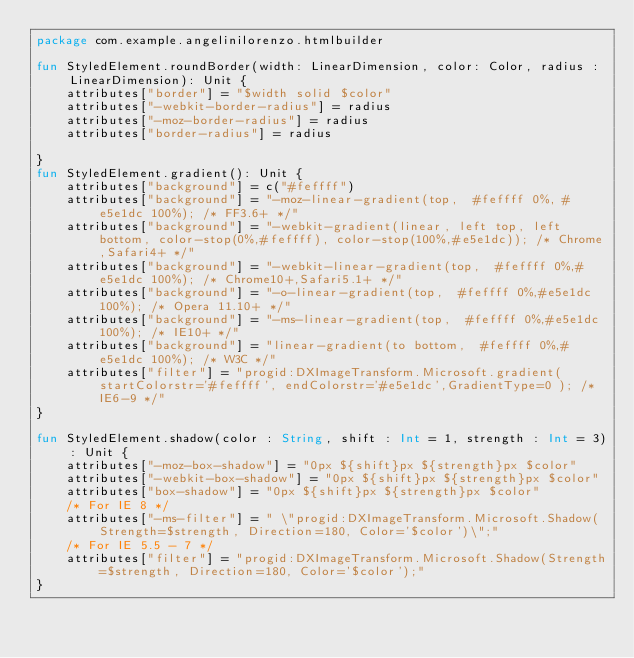Convert code to text. <code><loc_0><loc_0><loc_500><loc_500><_Kotlin_>package com.example.angelinilorenzo.htmlbuilder

fun StyledElement.roundBorder(width: LinearDimension, color: Color, radius : LinearDimension): Unit {
    attributes["border"] = "$width solid $color"
    attributes["-webkit-border-radius"] = radius
    attributes["-moz-border-radius"] = radius
    attributes["border-radius"] = radius

}
fun StyledElement.gradient(): Unit {
    attributes["background"] = c("#feffff")
    attributes["background"] = "-moz-linear-gradient(top,  #feffff 0%, #e5e1dc 100%); /* FF3.6+ */"
    attributes["background"] = "-webkit-gradient(linear, left top, left bottom, color-stop(0%,#feffff), color-stop(100%,#e5e1dc)); /* Chrome,Safari4+ */"
    attributes["background"] = "-webkit-linear-gradient(top,  #feffff 0%,#e5e1dc 100%); /* Chrome10+,Safari5.1+ */"
    attributes["background"] = "-o-linear-gradient(top,  #feffff 0%,#e5e1dc 100%); /* Opera 11.10+ */"
    attributes["background"] = "-ms-linear-gradient(top,  #feffff 0%,#e5e1dc 100%); /* IE10+ */"
    attributes["background"] = "linear-gradient(to bottom,  #feffff 0%,#e5e1dc 100%); /* W3C */"
    attributes["filter"] = "progid:DXImageTransform.Microsoft.gradient( startColorstr='#feffff', endColorstr='#e5e1dc',GradientType=0 ); /* IE6-9 */"
}

fun StyledElement.shadow(color : String, shift : Int = 1, strength : Int = 3): Unit {
    attributes["-moz-box-shadow"] = "0px ${shift}px ${strength}px $color"
    attributes["-webkit-box-shadow"] = "0px ${shift}px ${strength}px $color"
    attributes["box-shadow"] = "0px ${shift}px ${strength}px $color"
    /* For IE 8 */
    attributes["-ms-filter"] = " \"progid:DXImageTransform.Microsoft.Shadow(Strength=$strength, Direction=180, Color='$color')\";"
    /* For IE 5.5 - 7 */
    attributes["filter"] = "progid:DXImageTransform.Microsoft.Shadow(Strength=$strength, Direction=180, Color='$color');"
}
</code> 